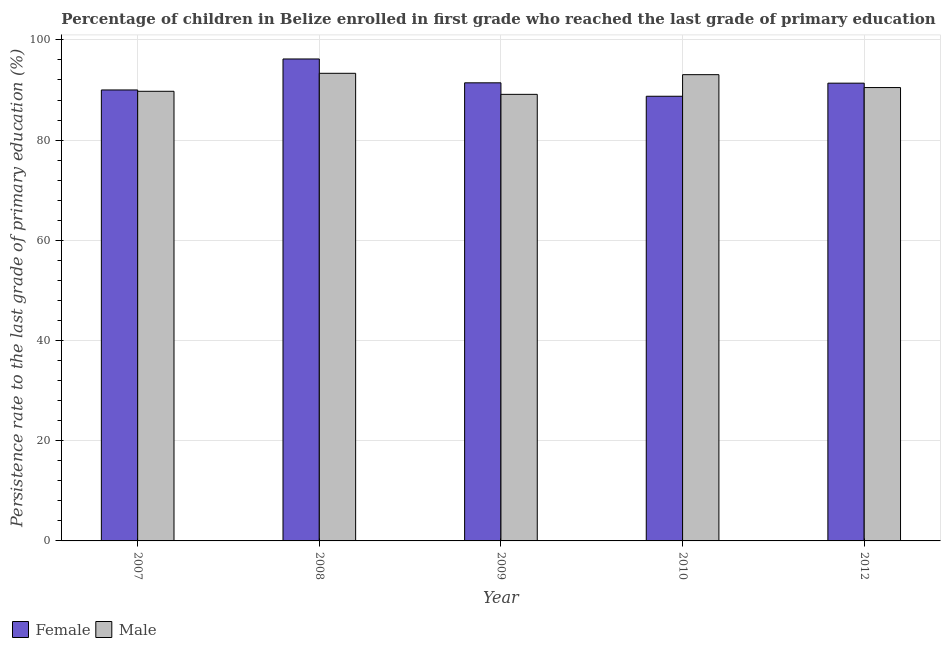How many different coloured bars are there?
Ensure brevity in your answer.  2. Are the number of bars per tick equal to the number of legend labels?
Provide a succinct answer. Yes. How many bars are there on the 4th tick from the left?
Offer a very short reply. 2. In how many cases, is the number of bars for a given year not equal to the number of legend labels?
Make the answer very short. 0. What is the persistence rate of male students in 2008?
Keep it short and to the point. 93.33. Across all years, what is the maximum persistence rate of female students?
Offer a terse response. 96.19. Across all years, what is the minimum persistence rate of male students?
Ensure brevity in your answer.  89.13. In which year was the persistence rate of male students maximum?
Make the answer very short. 2008. What is the total persistence rate of male students in the graph?
Keep it short and to the point. 455.76. What is the difference between the persistence rate of male students in 2007 and that in 2010?
Keep it short and to the point. -3.32. What is the difference between the persistence rate of male students in 2009 and the persistence rate of female students in 2010?
Ensure brevity in your answer.  -3.93. What is the average persistence rate of male students per year?
Ensure brevity in your answer.  91.15. In the year 2009, what is the difference between the persistence rate of female students and persistence rate of male students?
Your answer should be very brief. 0. In how many years, is the persistence rate of female students greater than 44 %?
Provide a succinct answer. 5. What is the ratio of the persistence rate of male students in 2007 to that in 2010?
Your answer should be compact. 0.96. What is the difference between the highest and the second highest persistence rate of male students?
Make the answer very short. 0.27. What is the difference between the highest and the lowest persistence rate of female students?
Provide a succinct answer. 7.44. In how many years, is the persistence rate of male students greater than the average persistence rate of male students taken over all years?
Your answer should be very brief. 2. How many bars are there?
Provide a succinct answer. 10. What is the difference between two consecutive major ticks on the Y-axis?
Provide a short and direct response. 20. Does the graph contain any zero values?
Your response must be concise. No. How many legend labels are there?
Provide a short and direct response. 2. What is the title of the graph?
Give a very brief answer. Percentage of children in Belize enrolled in first grade who reached the last grade of primary education. What is the label or title of the X-axis?
Keep it short and to the point. Year. What is the label or title of the Y-axis?
Offer a very short reply. Persistence rate to the last grade of primary education (%). What is the Persistence rate to the last grade of primary education (%) of Female in 2007?
Offer a terse response. 90.01. What is the Persistence rate to the last grade of primary education (%) in Male in 2007?
Offer a terse response. 89.75. What is the Persistence rate to the last grade of primary education (%) of Female in 2008?
Make the answer very short. 96.19. What is the Persistence rate to the last grade of primary education (%) of Male in 2008?
Make the answer very short. 93.33. What is the Persistence rate to the last grade of primary education (%) in Female in 2009?
Your answer should be very brief. 91.43. What is the Persistence rate to the last grade of primary education (%) of Male in 2009?
Provide a short and direct response. 89.13. What is the Persistence rate to the last grade of primary education (%) of Female in 2010?
Provide a succinct answer. 88.75. What is the Persistence rate to the last grade of primary education (%) of Male in 2010?
Give a very brief answer. 93.06. What is the Persistence rate to the last grade of primary education (%) in Female in 2012?
Ensure brevity in your answer.  91.37. What is the Persistence rate to the last grade of primary education (%) of Male in 2012?
Your answer should be compact. 90.49. Across all years, what is the maximum Persistence rate to the last grade of primary education (%) in Female?
Make the answer very short. 96.19. Across all years, what is the maximum Persistence rate to the last grade of primary education (%) in Male?
Ensure brevity in your answer.  93.33. Across all years, what is the minimum Persistence rate to the last grade of primary education (%) in Female?
Your answer should be compact. 88.75. Across all years, what is the minimum Persistence rate to the last grade of primary education (%) in Male?
Give a very brief answer. 89.13. What is the total Persistence rate to the last grade of primary education (%) in Female in the graph?
Your response must be concise. 457.76. What is the total Persistence rate to the last grade of primary education (%) of Male in the graph?
Provide a succinct answer. 455.76. What is the difference between the Persistence rate to the last grade of primary education (%) in Female in 2007 and that in 2008?
Provide a succinct answer. -6.18. What is the difference between the Persistence rate to the last grade of primary education (%) of Male in 2007 and that in 2008?
Your answer should be very brief. -3.59. What is the difference between the Persistence rate to the last grade of primary education (%) in Female in 2007 and that in 2009?
Offer a terse response. -1.42. What is the difference between the Persistence rate to the last grade of primary education (%) of Male in 2007 and that in 2009?
Your answer should be compact. 0.61. What is the difference between the Persistence rate to the last grade of primary education (%) of Female in 2007 and that in 2010?
Your answer should be very brief. 1.26. What is the difference between the Persistence rate to the last grade of primary education (%) in Male in 2007 and that in 2010?
Keep it short and to the point. -3.32. What is the difference between the Persistence rate to the last grade of primary education (%) of Female in 2007 and that in 2012?
Give a very brief answer. -1.36. What is the difference between the Persistence rate to the last grade of primary education (%) of Male in 2007 and that in 2012?
Give a very brief answer. -0.75. What is the difference between the Persistence rate to the last grade of primary education (%) in Female in 2008 and that in 2009?
Give a very brief answer. 4.76. What is the difference between the Persistence rate to the last grade of primary education (%) in Male in 2008 and that in 2009?
Your response must be concise. 4.2. What is the difference between the Persistence rate to the last grade of primary education (%) in Female in 2008 and that in 2010?
Provide a succinct answer. 7.44. What is the difference between the Persistence rate to the last grade of primary education (%) in Male in 2008 and that in 2010?
Make the answer very short. 0.27. What is the difference between the Persistence rate to the last grade of primary education (%) of Female in 2008 and that in 2012?
Your response must be concise. 4.83. What is the difference between the Persistence rate to the last grade of primary education (%) of Male in 2008 and that in 2012?
Your answer should be very brief. 2.84. What is the difference between the Persistence rate to the last grade of primary education (%) in Female in 2009 and that in 2010?
Keep it short and to the point. 2.68. What is the difference between the Persistence rate to the last grade of primary education (%) of Male in 2009 and that in 2010?
Offer a very short reply. -3.93. What is the difference between the Persistence rate to the last grade of primary education (%) of Female in 2009 and that in 2012?
Your answer should be very brief. 0.07. What is the difference between the Persistence rate to the last grade of primary education (%) of Male in 2009 and that in 2012?
Your answer should be compact. -1.36. What is the difference between the Persistence rate to the last grade of primary education (%) of Female in 2010 and that in 2012?
Provide a short and direct response. -2.62. What is the difference between the Persistence rate to the last grade of primary education (%) of Male in 2010 and that in 2012?
Give a very brief answer. 2.57. What is the difference between the Persistence rate to the last grade of primary education (%) in Female in 2007 and the Persistence rate to the last grade of primary education (%) in Male in 2008?
Your answer should be very brief. -3.32. What is the difference between the Persistence rate to the last grade of primary education (%) in Female in 2007 and the Persistence rate to the last grade of primary education (%) in Male in 2009?
Keep it short and to the point. 0.88. What is the difference between the Persistence rate to the last grade of primary education (%) in Female in 2007 and the Persistence rate to the last grade of primary education (%) in Male in 2010?
Keep it short and to the point. -3.05. What is the difference between the Persistence rate to the last grade of primary education (%) in Female in 2007 and the Persistence rate to the last grade of primary education (%) in Male in 2012?
Offer a terse response. -0.48. What is the difference between the Persistence rate to the last grade of primary education (%) of Female in 2008 and the Persistence rate to the last grade of primary education (%) of Male in 2009?
Offer a very short reply. 7.06. What is the difference between the Persistence rate to the last grade of primary education (%) of Female in 2008 and the Persistence rate to the last grade of primary education (%) of Male in 2010?
Your answer should be compact. 3.13. What is the difference between the Persistence rate to the last grade of primary education (%) in Female in 2008 and the Persistence rate to the last grade of primary education (%) in Male in 2012?
Your answer should be compact. 5.7. What is the difference between the Persistence rate to the last grade of primary education (%) of Female in 2009 and the Persistence rate to the last grade of primary education (%) of Male in 2010?
Make the answer very short. -1.63. What is the difference between the Persistence rate to the last grade of primary education (%) in Female in 2009 and the Persistence rate to the last grade of primary education (%) in Male in 2012?
Your answer should be very brief. 0.94. What is the difference between the Persistence rate to the last grade of primary education (%) of Female in 2010 and the Persistence rate to the last grade of primary education (%) of Male in 2012?
Provide a short and direct response. -1.74. What is the average Persistence rate to the last grade of primary education (%) in Female per year?
Provide a short and direct response. 91.55. What is the average Persistence rate to the last grade of primary education (%) of Male per year?
Your response must be concise. 91.15. In the year 2007, what is the difference between the Persistence rate to the last grade of primary education (%) of Female and Persistence rate to the last grade of primary education (%) of Male?
Provide a succinct answer. 0.26. In the year 2008, what is the difference between the Persistence rate to the last grade of primary education (%) of Female and Persistence rate to the last grade of primary education (%) of Male?
Your response must be concise. 2.86. In the year 2009, what is the difference between the Persistence rate to the last grade of primary education (%) of Female and Persistence rate to the last grade of primary education (%) of Male?
Your response must be concise. 2.3. In the year 2010, what is the difference between the Persistence rate to the last grade of primary education (%) of Female and Persistence rate to the last grade of primary education (%) of Male?
Offer a terse response. -4.31. In the year 2012, what is the difference between the Persistence rate to the last grade of primary education (%) of Female and Persistence rate to the last grade of primary education (%) of Male?
Make the answer very short. 0.88. What is the ratio of the Persistence rate to the last grade of primary education (%) of Female in 2007 to that in 2008?
Your answer should be very brief. 0.94. What is the ratio of the Persistence rate to the last grade of primary education (%) of Male in 2007 to that in 2008?
Make the answer very short. 0.96. What is the ratio of the Persistence rate to the last grade of primary education (%) in Female in 2007 to that in 2009?
Offer a terse response. 0.98. What is the ratio of the Persistence rate to the last grade of primary education (%) of Male in 2007 to that in 2009?
Keep it short and to the point. 1.01. What is the ratio of the Persistence rate to the last grade of primary education (%) of Female in 2007 to that in 2010?
Offer a terse response. 1.01. What is the ratio of the Persistence rate to the last grade of primary education (%) in Male in 2007 to that in 2010?
Offer a terse response. 0.96. What is the ratio of the Persistence rate to the last grade of primary education (%) of Female in 2007 to that in 2012?
Keep it short and to the point. 0.99. What is the ratio of the Persistence rate to the last grade of primary education (%) of Female in 2008 to that in 2009?
Provide a succinct answer. 1.05. What is the ratio of the Persistence rate to the last grade of primary education (%) in Male in 2008 to that in 2009?
Provide a succinct answer. 1.05. What is the ratio of the Persistence rate to the last grade of primary education (%) in Female in 2008 to that in 2010?
Ensure brevity in your answer.  1.08. What is the ratio of the Persistence rate to the last grade of primary education (%) of Female in 2008 to that in 2012?
Provide a succinct answer. 1.05. What is the ratio of the Persistence rate to the last grade of primary education (%) of Male in 2008 to that in 2012?
Ensure brevity in your answer.  1.03. What is the ratio of the Persistence rate to the last grade of primary education (%) of Female in 2009 to that in 2010?
Make the answer very short. 1.03. What is the ratio of the Persistence rate to the last grade of primary education (%) of Male in 2009 to that in 2010?
Offer a very short reply. 0.96. What is the ratio of the Persistence rate to the last grade of primary education (%) in Male in 2009 to that in 2012?
Your answer should be very brief. 0.98. What is the ratio of the Persistence rate to the last grade of primary education (%) in Female in 2010 to that in 2012?
Keep it short and to the point. 0.97. What is the ratio of the Persistence rate to the last grade of primary education (%) of Male in 2010 to that in 2012?
Provide a short and direct response. 1.03. What is the difference between the highest and the second highest Persistence rate to the last grade of primary education (%) in Female?
Your answer should be very brief. 4.76. What is the difference between the highest and the second highest Persistence rate to the last grade of primary education (%) of Male?
Keep it short and to the point. 0.27. What is the difference between the highest and the lowest Persistence rate to the last grade of primary education (%) in Female?
Provide a short and direct response. 7.44. What is the difference between the highest and the lowest Persistence rate to the last grade of primary education (%) in Male?
Keep it short and to the point. 4.2. 